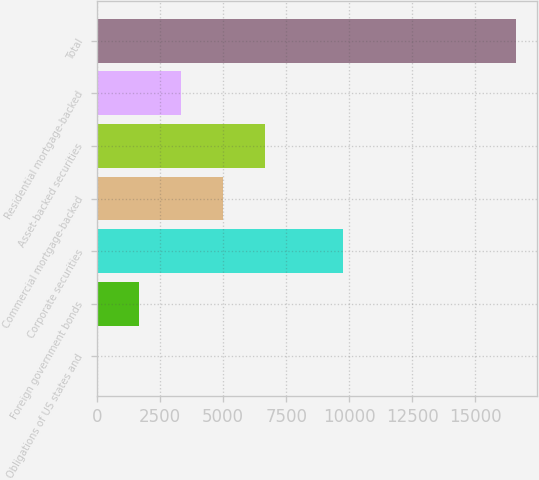<chart> <loc_0><loc_0><loc_500><loc_500><bar_chart><fcel>Obligations of US states and<fcel>Foreign government bonds<fcel>Corporate securities<fcel>Commercial mortgage-backed<fcel>Asset-backed securities<fcel>Residential mortgage-backed<fcel>Total<nl><fcel>12<fcel>1672.3<fcel>9732<fcel>4992.9<fcel>6653.2<fcel>3332.6<fcel>16615<nl></chart> 